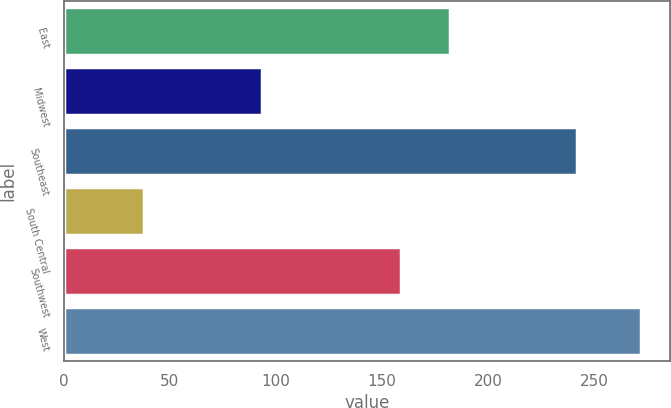Convert chart. <chart><loc_0><loc_0><loc_500><loc_500><bar_chart><fcel>East<fcel>Midwest<fcel>Southeast<fcel>South Central<fcel>Southwest<fcel>West<nl><fcel>182.08<fcel>93.6<fcel>241.7<fcel>38.1<fcel>158.7<fcel>271.9<nl></chart> 